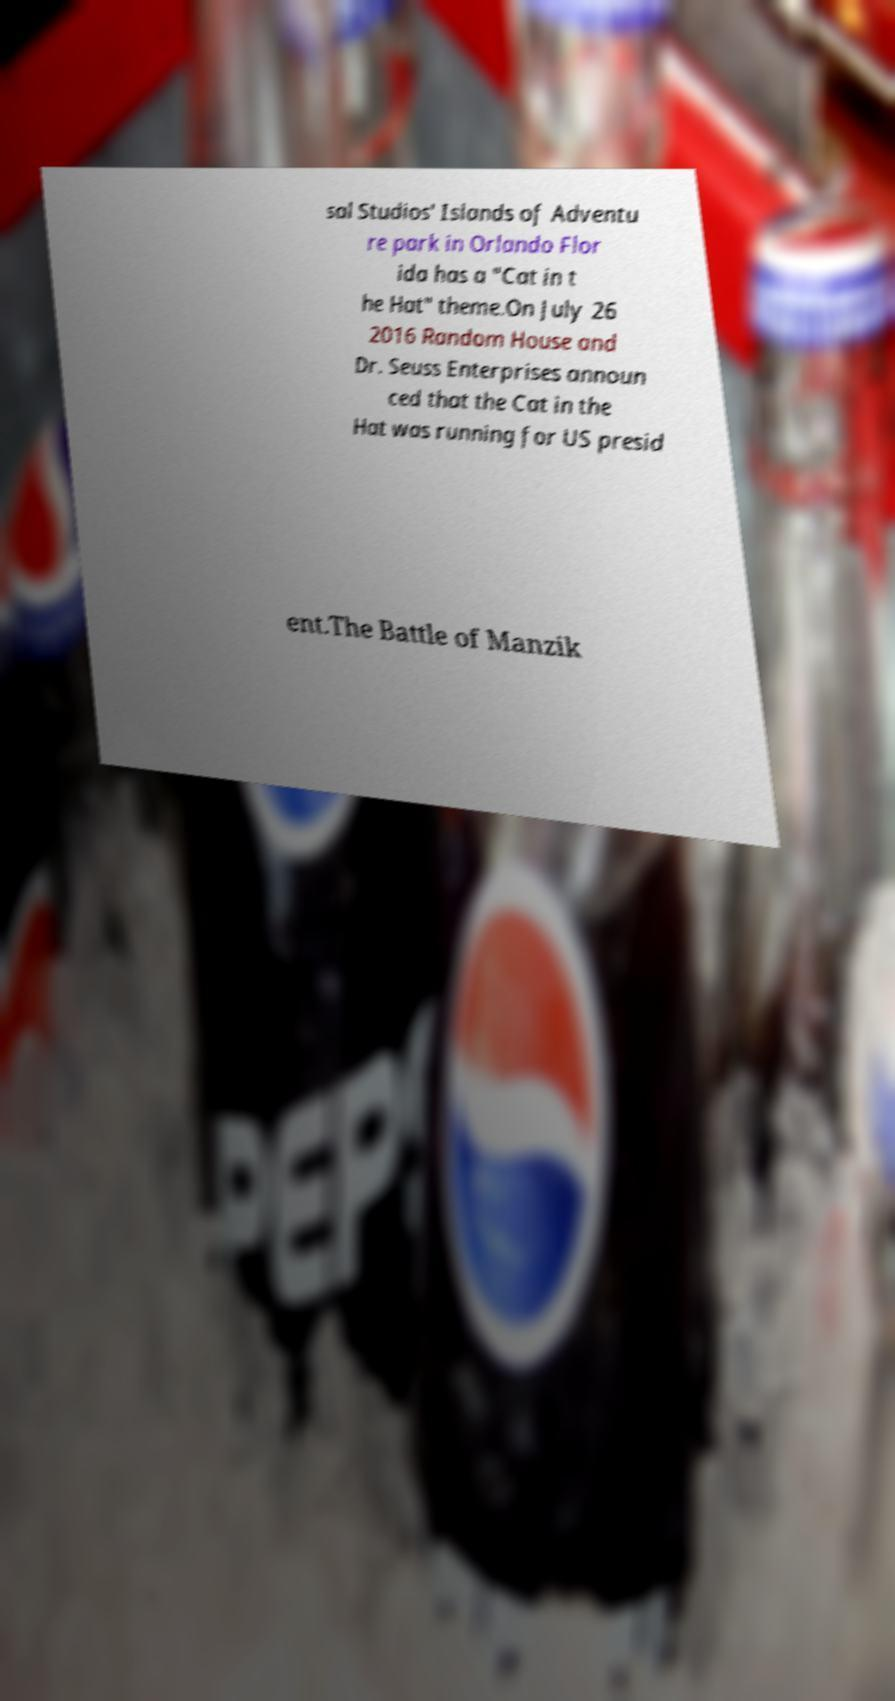For documentation purposes, I need the text within this image transcribed. Could you provide that? sal Studios' Islands of Adventu re park in Orlando Flor ida has a "Cat in t he Hat" theme.On July 26 2016 Random House and Dr. Seuss Enterprises announ ced that the Cat in the Hat was running for US presid ent.The Battle of Manzik 